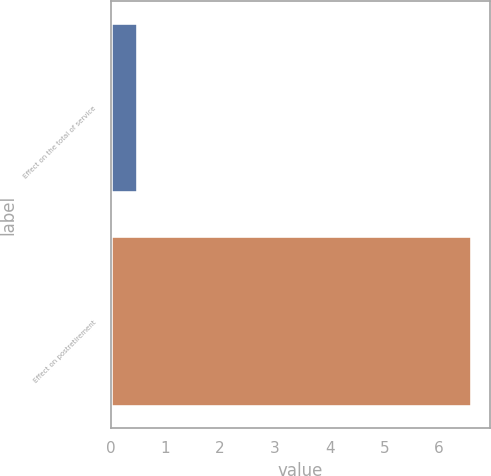Convert chart to OTSL. <chart><loc_0><loc_0><loc_500><loc_500><bar_chart><fcel>Effect on the total of service<fcel>Effect on postretirement<nl><fcel>0.5<fcel>6.6<nl></chart> 